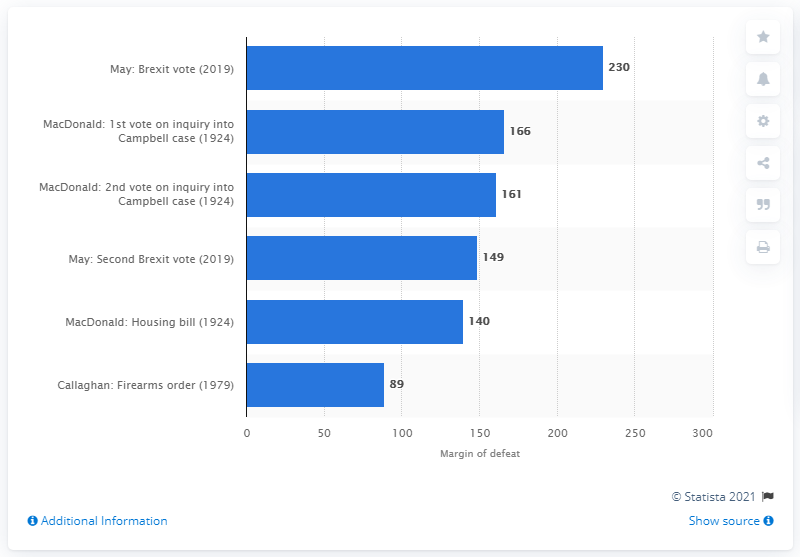Specify some key components in this picture. The Prime Minister's Brexit deal received 230 votes during the parliamentary vote. 